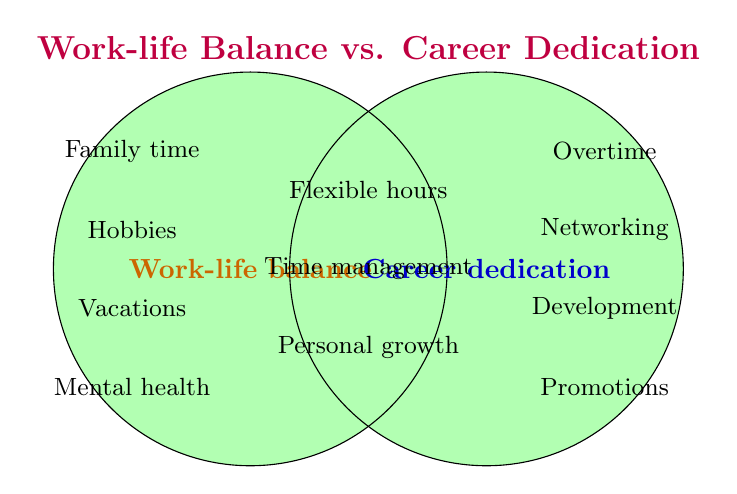What two categories are represented in the Venn Diagram? The Venn Diagram has two main categories labeled "Work-life balance" and "Career dedication." These categories are visually represented by two overlapping circles.
Answer: Work-life balance and Career dedication How many elements are in the "Both" category? The "Both" category, represented by the overlapping section, contains three elements: Flexible hours, Time management, and Personal growth.
Answer: 3 Which category does "Hobbies" belong to? "Hobbies" is located inside the circle labeled "Work-life balance," indicating that it belongs to the Work-life balance category.
Answer: Work-life balance What is the element at the intersection of the two circles that is related to "goal setting"? The element at the intersection of the circles that involves goal setting is implicitly part of time management and personal growth, which relate to effective goal setting.
Answer: Time management or Personal growth Does "Job promotions" belong to the "Work-life balance" circle? "Job promotions" is not inside the "Work-life balance" circle. It is in the "Career dedication" circle, meaning it belongs solely to Career dedication.
Answer: No Compare the number of elements solely in "Work-life balance" with those solely in "Career dedication." There are five elements solely in "Work-life balance" (Family time, Hobbies, Vacations, Mental health, Social life) and four elements solely in "Career dedication" (Overtime, Networking events, Professional development, Job promotions).
Answer: Work-life balance has more Identify one activity that falls under both Work-life balance and Career dedication. One activity that falls under both categories is "Time management."
Answer: Time management Do the categories of "Mental health" and "Professional development" overlap? "Mental health" belongs to the "Work-life balance" category, while "Professional development" is in the "Career dedication" category. These do not overlap in the Venn Diagram.
Answer: No How many activities belong exclusively to Career dedication? There are four activities that belong exclusively to Career dedication: Overtime, Networking events, Professional development, and Job promotions.
Answer: 4 